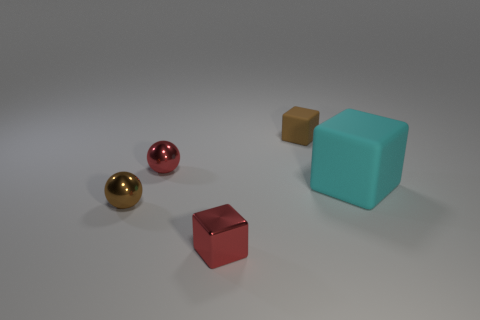There is a sphere that is the same color as the tiny matte cube; what is its size?
Give a very brief answer. Small. What number of objects are big yellow balls or things in front of the large cyan matte cube?
Keep it short and to the point. 2. There is a brown metallic ball; is it the same size as the red metallic thing that is left of the small red shiny cube?
Your response must be concise. Yes. What number of cylinders are either small brown rubber objects or large cyan things?
Your answer should be very brief. 0. What number of blocks are left of the big cyan matte block and behind the brown metal thing?
Give a very brief answer. 1. How many other objects are the same color as the metallic cube?
Ensure brevity in your answer.  1. There is a red shiny thing that is behind the small brown metal sphere; what is its shape?
Ensure brevity in your answer.  Sphere. Is the material of the red block the same as the tiny brown ball?
Make the answer very short. Yes. Are there any other things that have the same size as the cyan thing?
Give a very brief answer. No. What number of small shiny cubes are behind the brown cube?
Make the answer very short. 0. 